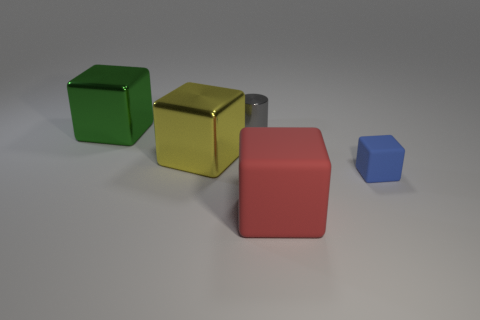Subtract all blue cubes. How many cubes are left? 3 Add 1 green objects. How many objects exist? 6 Subtract all blue cubes. How many cubes are left? 3 Subtract all cubes. How many objects are left? 1 Subtract 3 cubes. How many cubes are left? 1 Add 4 big red things. How many big red things are left? 5 Add 3 large gray balls. How many large gray balls exist? 3 Subtract 0 yellow spheres. How many objects are left? 5 Subtract all red cubes. Subtract all purple cylinders. How many cubes are left? 3 Subtract all blue cylinders. How many green cubes are left? 1 